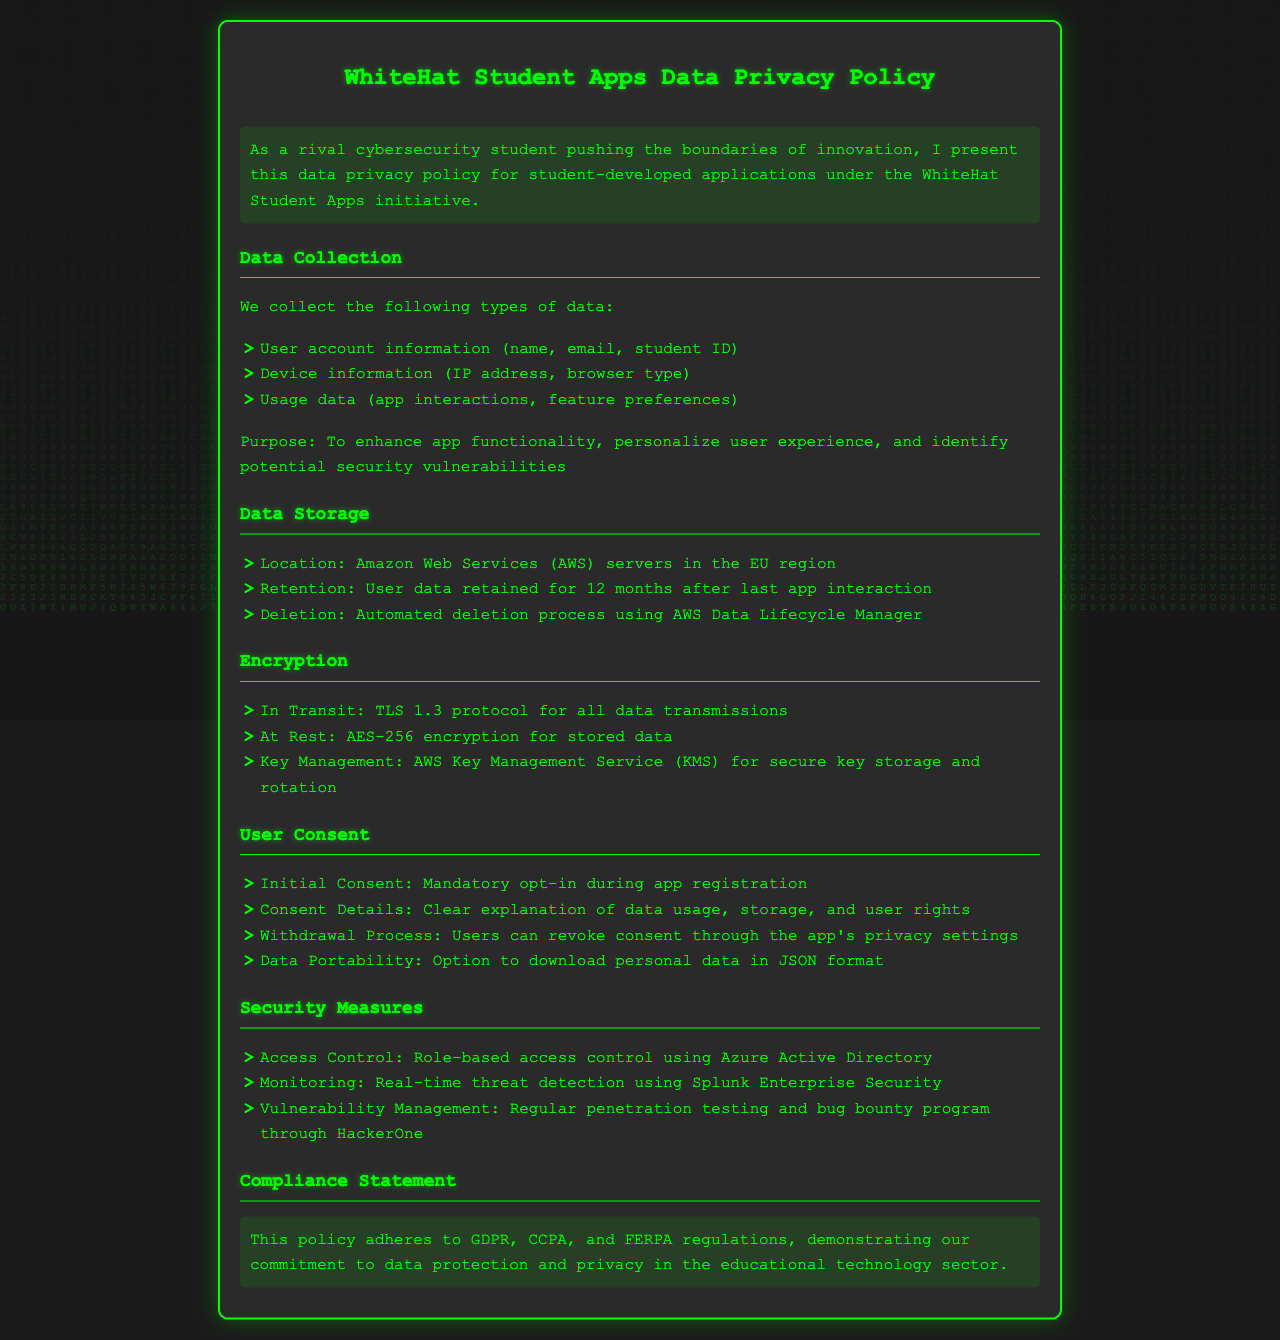What types of data are collected? The document lists three types of data collected: user account information, device information, and usage data.
Answer: User account information, device information, usage data Where is user data stored? The document specifies the user data storage location as being on Amazon Web Services servers in a certain region.
Answer: Amazon Web Services (AWS) servers in the EU region What encryption method is used for data at rest? The document mentions the specific encryption standard used for stored data.
Answer: AES-256 How long is user data retained? The document states the retention period for user data after the last app interaction.
Answer: 12 months What is the process to revoke user consent? The document details how users can manage their consent regarding data usage.
Answer: Through the app's privacy settings Which protocol is used for data transmission? The document describes the secure protocol implemented for all data transmissions.
Answer: TLS 1.3 What compliance regulations are mentioned? The document identifies key regulations that the policy adheres to regarding data protection.
Answer: GDPR, CCPA, FERPA What is the purpose of data collection? The document outlines the main reasons for collecting user data from apps.
Answer: Enhance app functionality, personalize user experience, identify security vulnerabilities What service is used for key management? The document specifies which service is utilized for securely managing encryption keys.
Answer: AWS Key Management Service (KMS) 